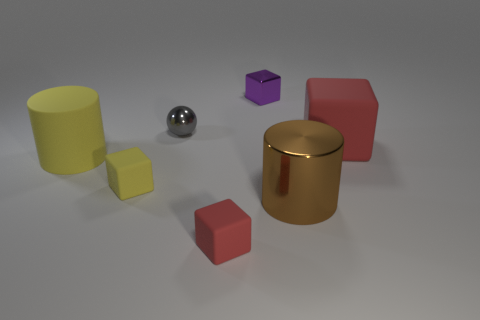How many objects are either purple matte cylinders or tiny things?
Keep it short and to the point. 4. Are the big object that is in front of the tiny yellow rubber object and the red thing behind the yellow cylinder made of the same material?
Your answer should be very brief. No. What is the color of the large cylinder that is made of the same material as the purple thing?
Give a very brief answer. Brown. What number of red cubes have the same size as the gray object?
Offer a terse response. 1. How many other things are there of the same color as the big metallic cylinder?
Ensure brevity in your answer.  0. Is there any other thing that is the same size as the shiny cylinder?
Provide a short and direct response. Yes. There is a red rubber object in front of the brown object; does it have the same shape as the big object left of the small yellow block?
Your response must be concise. No. What is the shape of the gray object that is the same size as the yellow matte block?
Offer a terse response. Sphere. Are there the same number of large red rubber things that are left of the purple metal object and tiny gray shiny objects that are on the right side of the shiny cylinder?
Provide a succinct answer. Yes. Are there any other things that have the same shape as the tiny gray metallic thing?
Provide a succinct answer. No. 